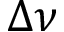<formula> <loc_0><loc_0><loc_500><loc_500>\Delta \nu</formula> 